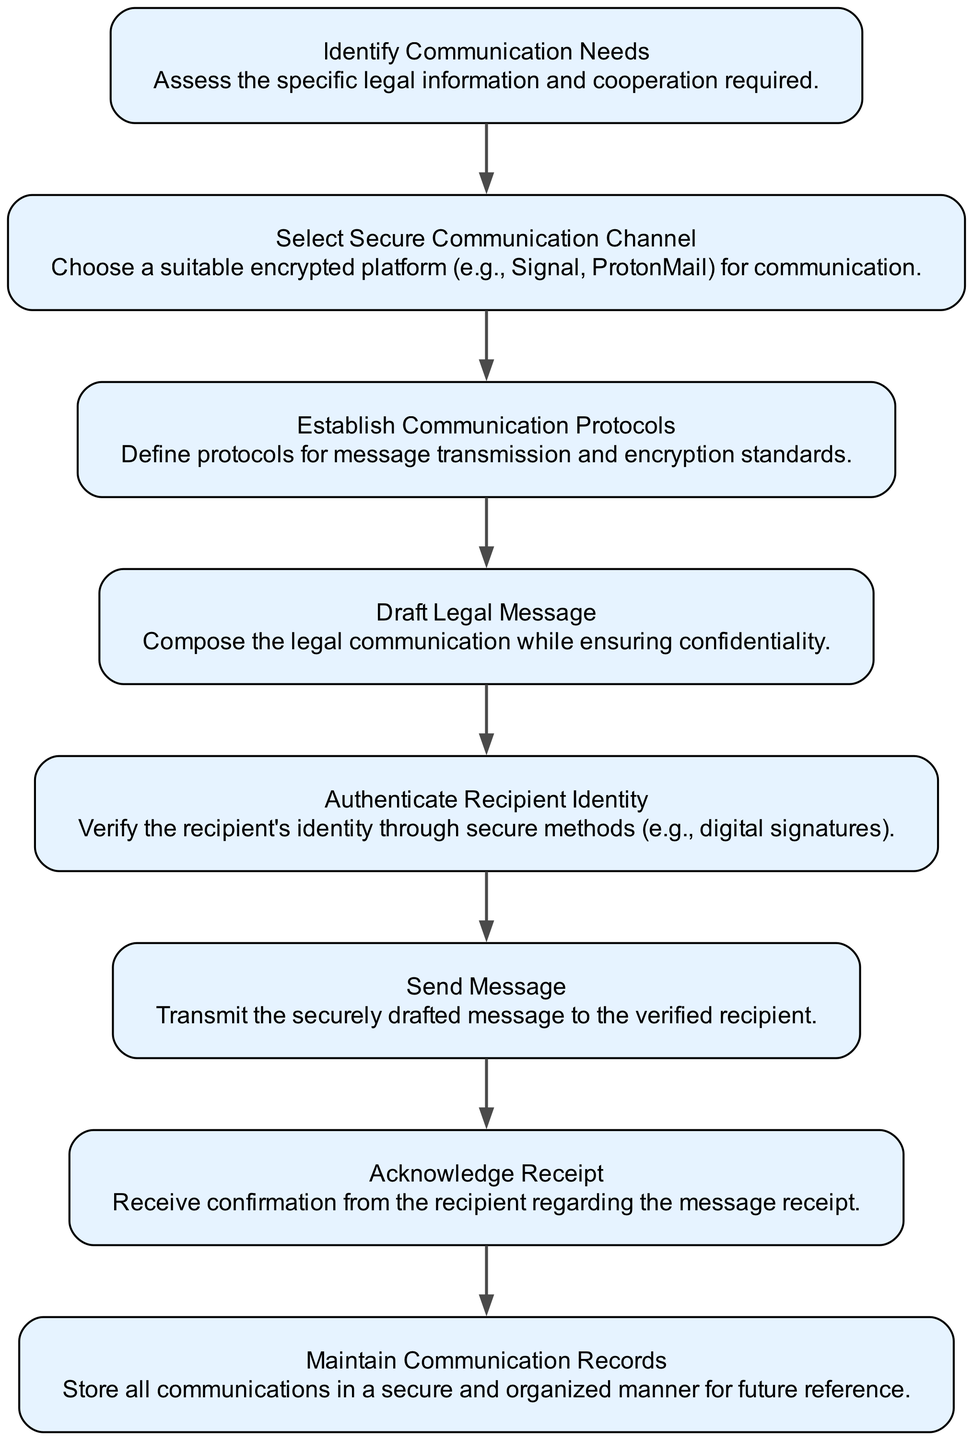What is the first step in the process? The first step in the flow chart is "Identify Communication Needs." This is indicated as the initial node in the diagram, which signifies that the process starts with assessing legal information and cooperation requirements.
Answer: Identify Communication Needs How many nodes are present in the diagram? The diagram contains a total of eight nodes representing different steps in the communication process. Each step is depicted as a separate node.
Answer: Eight What step involves validating the recipient? The step that involves validating the recipient is "Authenticate Recipient Identity." This is specifically mentioned to ensure that the identity of the person receiving the message is confirmed through secure methods.
Answer: Authenticate Recipient Identity Which steps are directly connected? The steps that are directly connected in the flow chart are: "Identify Communication Needs" to "Select Secure Communication Channel," "Select Secure Communication Channel" to "Establish Communication Protocols," and so forth, as it follows a sequential flow through the process.
Answer: Various sequential connections What step follows "Draft Legal Message"? The step that follows "Draft Legal Message" is "Authenticate Recipient Identity." This indicates that after composing the message, it is important to verify the recipient's identity before sending it.
Answer: Authenticate Recipient Identity What are the last two steps in the process? The last two steps in the flow chart are "Acknowledge Receipt" and "Maintain Communication Records." These steps conclude the process by confirming receipt of the message and ensuring that all communications are securely stored for future reference.
Answer: Acknowledge Receipt, Maintain Communication Records Which step comes before the message is sent? The step that comes before the message is sent is "Authenticate Recipient Identity." This is crucial, as it ensures that the recipient is verified prior to transmitting the securely drafted message.
Answer: Authenticate Recipient Identity What is the essential purpose of the diagram? The essential purpose of the diagram is to outline the Process of Secure Communication for International Legal Collaborations, detailing the necessary steps for secure and effective communication in legal contexts.
Answer: Secure Communication Process 